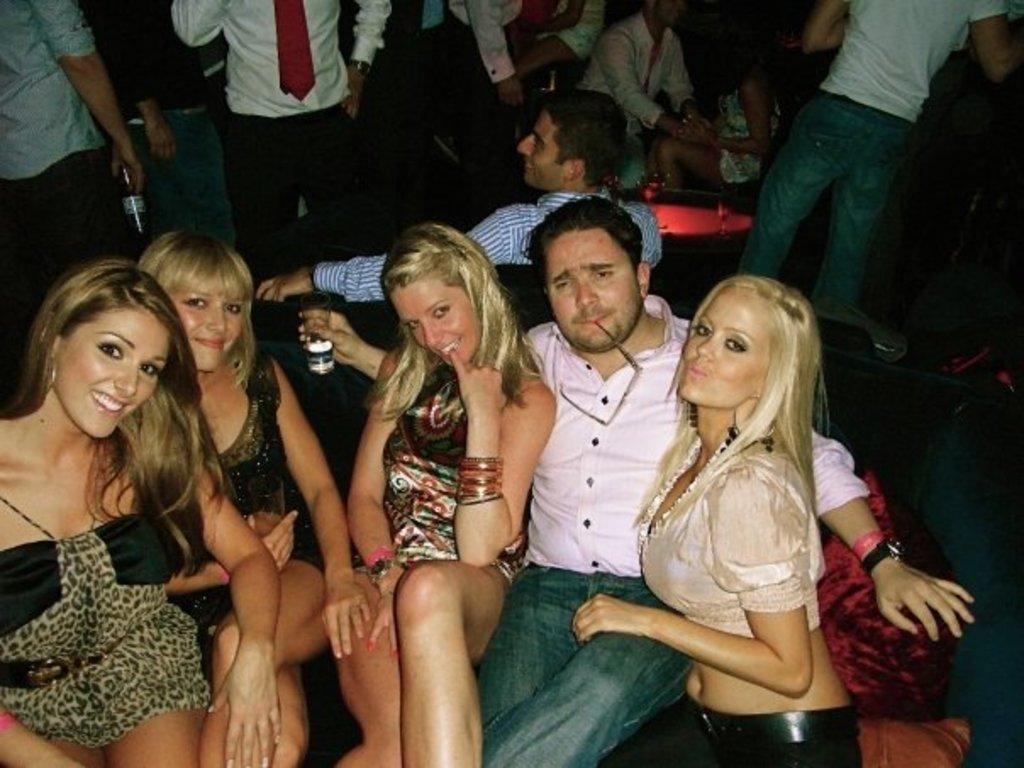How would you summarize this image in a sentence or two? This image consists of many people. In the front, there is a man sitting with four girls on the couch. In the background, there are many people. Its look like a pub. 